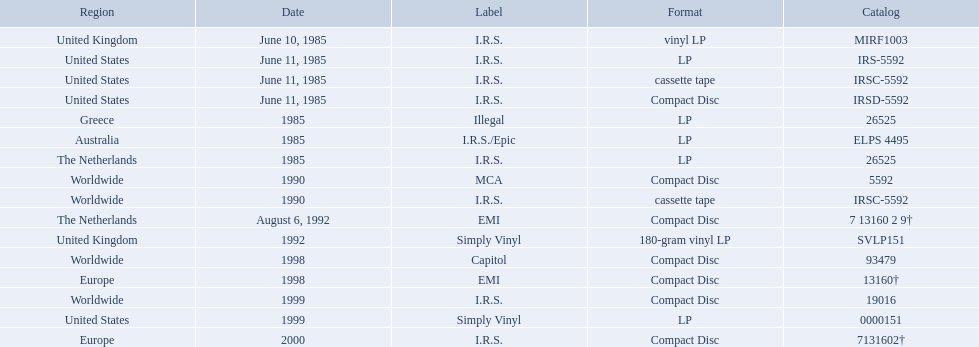In which regions was the fables of the reconstruction album released? United Kingdom, United States, United States, United States, Greece, Australia, The Netherlands, Worldwide, Worldwide, The Netherlands, United Kingdom, Worldwide, Europe, Worldwide, United States, Europe. And what were the release dates for those regions? June 10, 1985, June 11, 1985, June 11, 1985, June 11, 1985, 1985, 1985, 1985, 1990, 1990, August 6, 1992, 1992, 1998, 1998, 1999, 1999, 2000. And which region was listed after greece in 1985? Australia. In which zones was the "fables of the reconstruction" album introduced? United Kingdom, United States, United States, United States, Greece, Australia, The Netherlands, Worldwide, Worldwide, The Netherlands, United Kingdom, Worldwide, Europe, Worldwide, United States, Europe. And what were the introduction dates for those zones? June 10, 1985, June 11, 1985, June 11, 1985, June 11, 1985, 1985, 1985, 1985, 1990, 1990, August 6, 1992, 1992, 1998, 1998, 1999, 1999, 2000. And which zone was cited after greece in 1985? Australia. What dates were vinyl records of any type launched? June 10, 1985, June 11, 1985, 1985, 1985, 1985, 1992, 1999. In which nations were these introduced by i.r.s.? United Kingdom, United States, Australia, The Netherlands. Which of these nations is not situated in the northern hemisphere? Australia. What were the release dates for fables of the reconstruction? June 10, 1985, June 11, 1985, June 11, 1985, June 11, 1985, 1985, 1985, 1985, 1990, 1990, August 6, 1992, 1992, 1998, 1998, 1999, 1999, 2000. Which ones happened in 1985? June 10, 1985, June 11, 1985, June 11, 1985, June 11, 1985, 1985, 1985, 1985. In which territories were the releases done on these dates? United Kingdom, United States, United States, United States, Greece, Australia, The Netherlands. Which of these territories are not greece? United Kingdom, United States, United States, United States, Australia, The Netherlands. Which of these territories have two labels listed? Australia. On what dates were any kind of lps made available? June 10, 1985, June 11, 1985, 1985, 1985, 1985, 1992, 1999. In which countries did i.r.s. release these? United Kingdom, United States, Australia, The Netherlands. Which among these countries does not belong to the northern hemisphere? Australia. 